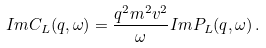<formula> <loc_0><loc_0><loc_500><loc_500>I m C _ { L } ( q , \omega ) = \frac { q ^ { 2 } m ^ { 2 } v ^ { 2 } } { \omega } I m P _ { L } ( q , \omega ) \, .</formula> 